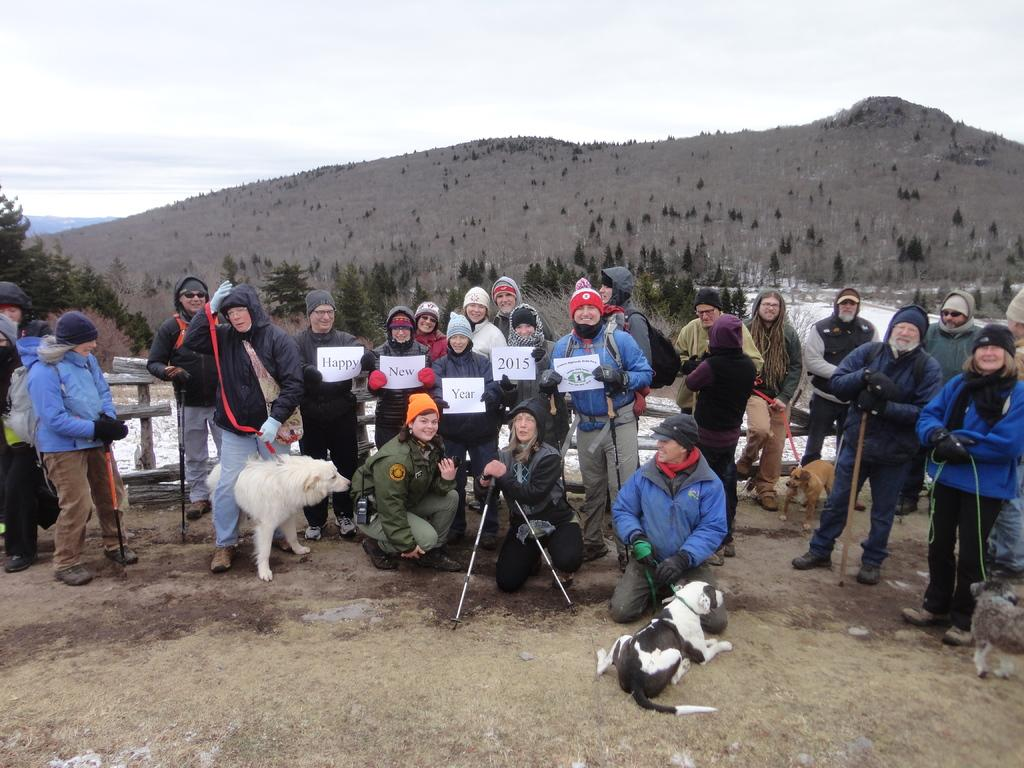How many people are in the group shown in the image? There is a group of people in the image, but the exact number is not specified. What are some people in the group holding? Some people in the group are holding boards and dogs. What can be seen in the background of the image? A: There is a mountain and the sky visible in the background of the image. What time of day is it in the image, and how many cows are grazing in the field? The time of day is not specified in the image, and there are no cows present. 